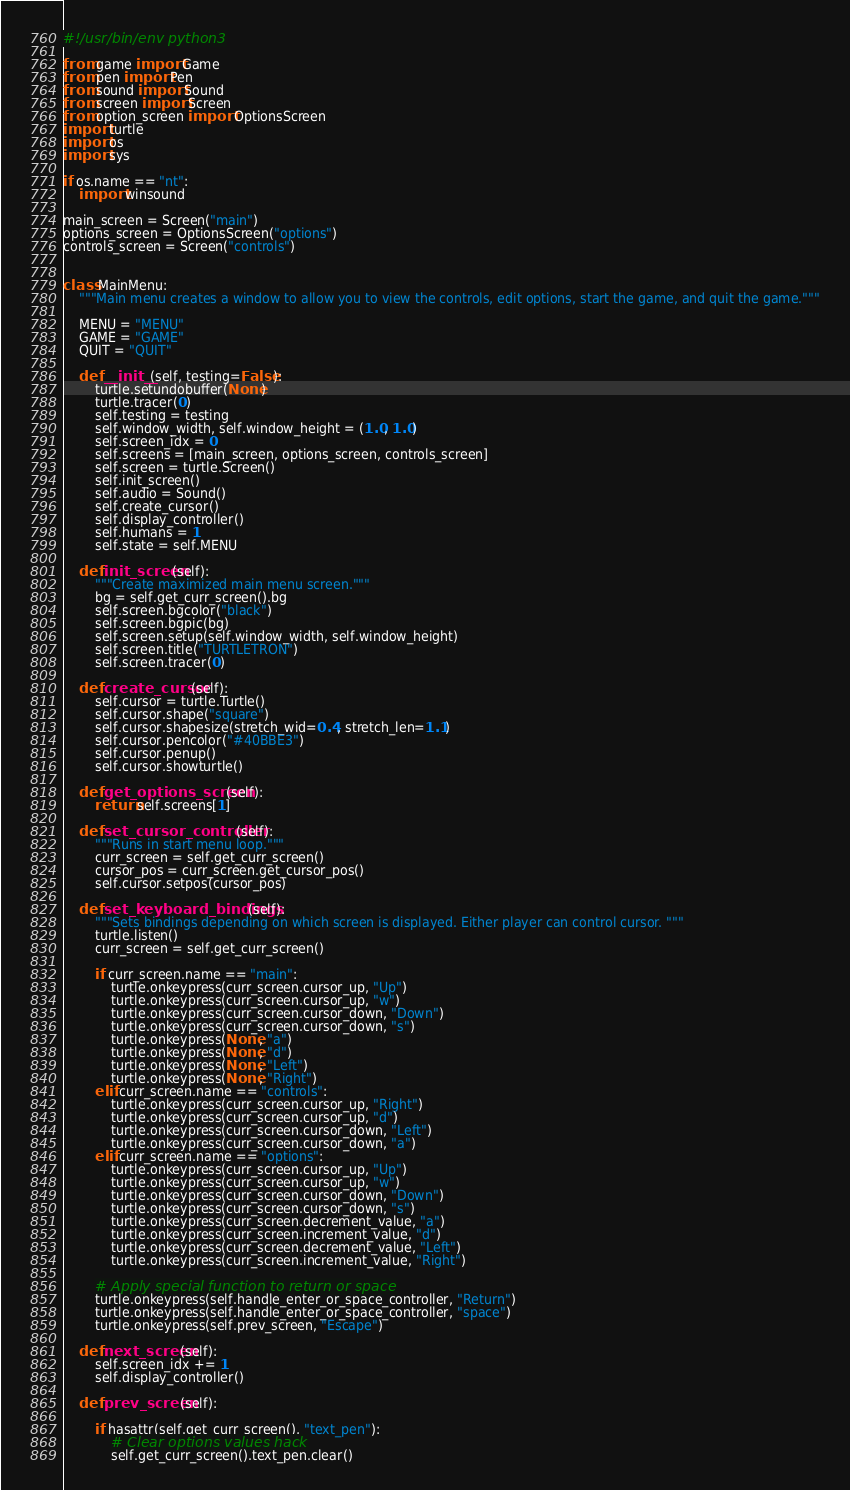<code> <loc_0><loc_0><loc_500><loc_500><_Python_>#!/usr/bin/env python3

from game import Game
from pen import Pen
from sound import Sound
from screen import Screen
from option_screen import OptionsScreen
import turtle
import os
import sys

if os.name == "nt":
    import winsound

main_screen = Screen("main")
options_screen = OptionsScreen("options")
controls_screen = Screen("controls")


class MainMenu:
    """Main menu creates a window to allow you to view the controls, edit options, start the game, and quit the game."""

    MENU = "MENU"
    GAME = "GAME"
    QUIT = "QUIT"

    def __init__(self, testing=False):
        turtle.setundobuffer(None)
        turtle.tracer(0)
        self.testing = testing
        self.window_width, self.window_height = (1.0, 1.0)
        self.screen_idx = 0
        self.screens = [main_screen, options_screen, controls_screen]
        self.screen = turtle.Screen()
        self.init_screen()
        self.audio = Sound()
        self.create_cursor()
        self.display_controller()
        self.humans = 1
        self.state = self.MENU

    def init_screen(self):
        """Create maximized main menu screen."""
        bg = self.get_curr_screen().bg
        self.screen.bgcolor("black")
        self.screen.bgpic(bg)
        self.screen.setup(self.window_width, self.window_height)
        self.screen.title("TURTLETRON")
        self.screen.tracer(0)

    def create_cursor(self):
        self.cursor = turtle.Turtle()
        self.cursor.shape("square")
        self.cursor.shapesize(stretch_wid=0.4, stretch_len=1.1)
        self.cursor.pencolor("#40BBE3")
        self.cursor.penup()
        self.cursor.showturtle()

    def get_options_screen(self):
        return self.screens[1]

    def set_cursor_controller(self):
        """Runs in start menu loop."""
        curr_screen = self.get_curr_screen()
        cursor_pos = curr_screen.get_cursor_pos()
        self.cursor.setpos(cursor_pos)

    def set_keyboard_bindings(self):
        """Sets bindings depending on which screen is displayed. Either player can control cursor. """
        turtle.listen()
        curr_screen = self.get_curr_screen()

        if curr_screen.name == "main":
            turtle.onkeypress(curr_screen.cursor_up, "Up")
            turtle.onkeypress(curr_screen.cursor_up, "w")
            turtle.onkeypress(curr_screen.cursor_down, "Down")
            turtle.onkeypress(curr_screen.cursor_down, "s")
            turtle.onkeypress(None, "a")
            turtle.onkeypress(None, "d")
            turtle.onkeypress(None, "Left")
            turtle.onkeypress(None, "Right")
        elif curr_screen.name == "controls":
            turtle.onkeypress(curr_screen.cursor_up, "Right")
            turtle.onkeypress(curr_screen.cursor_up, "d")
            turtle.onkeypress(curr_screen.cursor_down, "Left")
            turtle.onkeypress(curr_screen.cursor_down, "a")
        elif curr_screen.name == "options":
            turtle.onkeypress(curr_screen.cursor_up, "Up")
            turtle.onkeypress(curr_screen.cursor_up, "w")
            turtle.onkeypress(curr_screen.cursor_down, "Down")
            turtle.onkeypress(curr_screen.cursor_down, "s")
            turtle.onkeypress(curr_screen.decrement_value, "a")
            turtle.onkeypress(curr_screen.increment_value, "d")
            turtle.onkeypress(curr_screen.decrement_value, "Left")
            turtle.onkeypress(curr_screen.increment_value, "Right")

        # Apply special function to return or space
        turtle.onkeypress(self.handle_enter_or_space_controller, "Return")
        turtle.onkeypress(self.handle_enter_or_space_controller, "space")
        turtle.onkeypress(self.prev_screen, "Escape")

    def next_screen(self):
        self.screen_idx += 1
        self.display_controller()

    def prev_screen(self):

        if hasattr(self.get_curr_screen(), "text_pen"):
            # Clear options values hack
            self.get_curr_screen().text_pen.clear()
</code> 